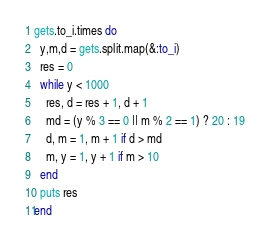Convert code to text. <code><loc_0><loc_0><loc_500><loc_500><_Ruby_>gets.to_i.times do
  y,m,d = gets.split.map(&:to_i)
  res = 0
  while y < 1000
    res, d = res + 1, d + 1
    md = (y % 3 == 0 || m % 2 == 1) ? 20 : 19
    d, m = 1, m + 1 if d > md
    m, y = 1, y + 1 if m > 10
  end
  puts res
end</code> 